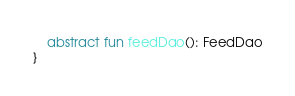Convert code to text. <code><loc_0><loc_0><loc_500><loc_500><_Kotlin_>
    abstract fun feedDao(): FeedDao
}
</code> 